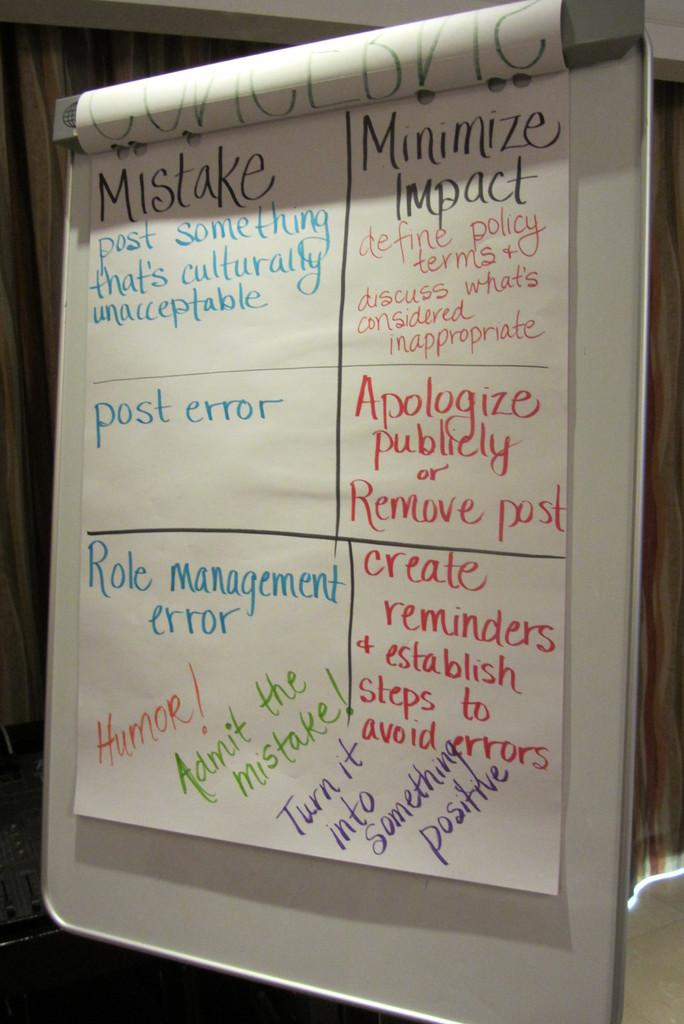<image>
Summarize the visual content of the image. a big note has words like Mistake and Humor on it 